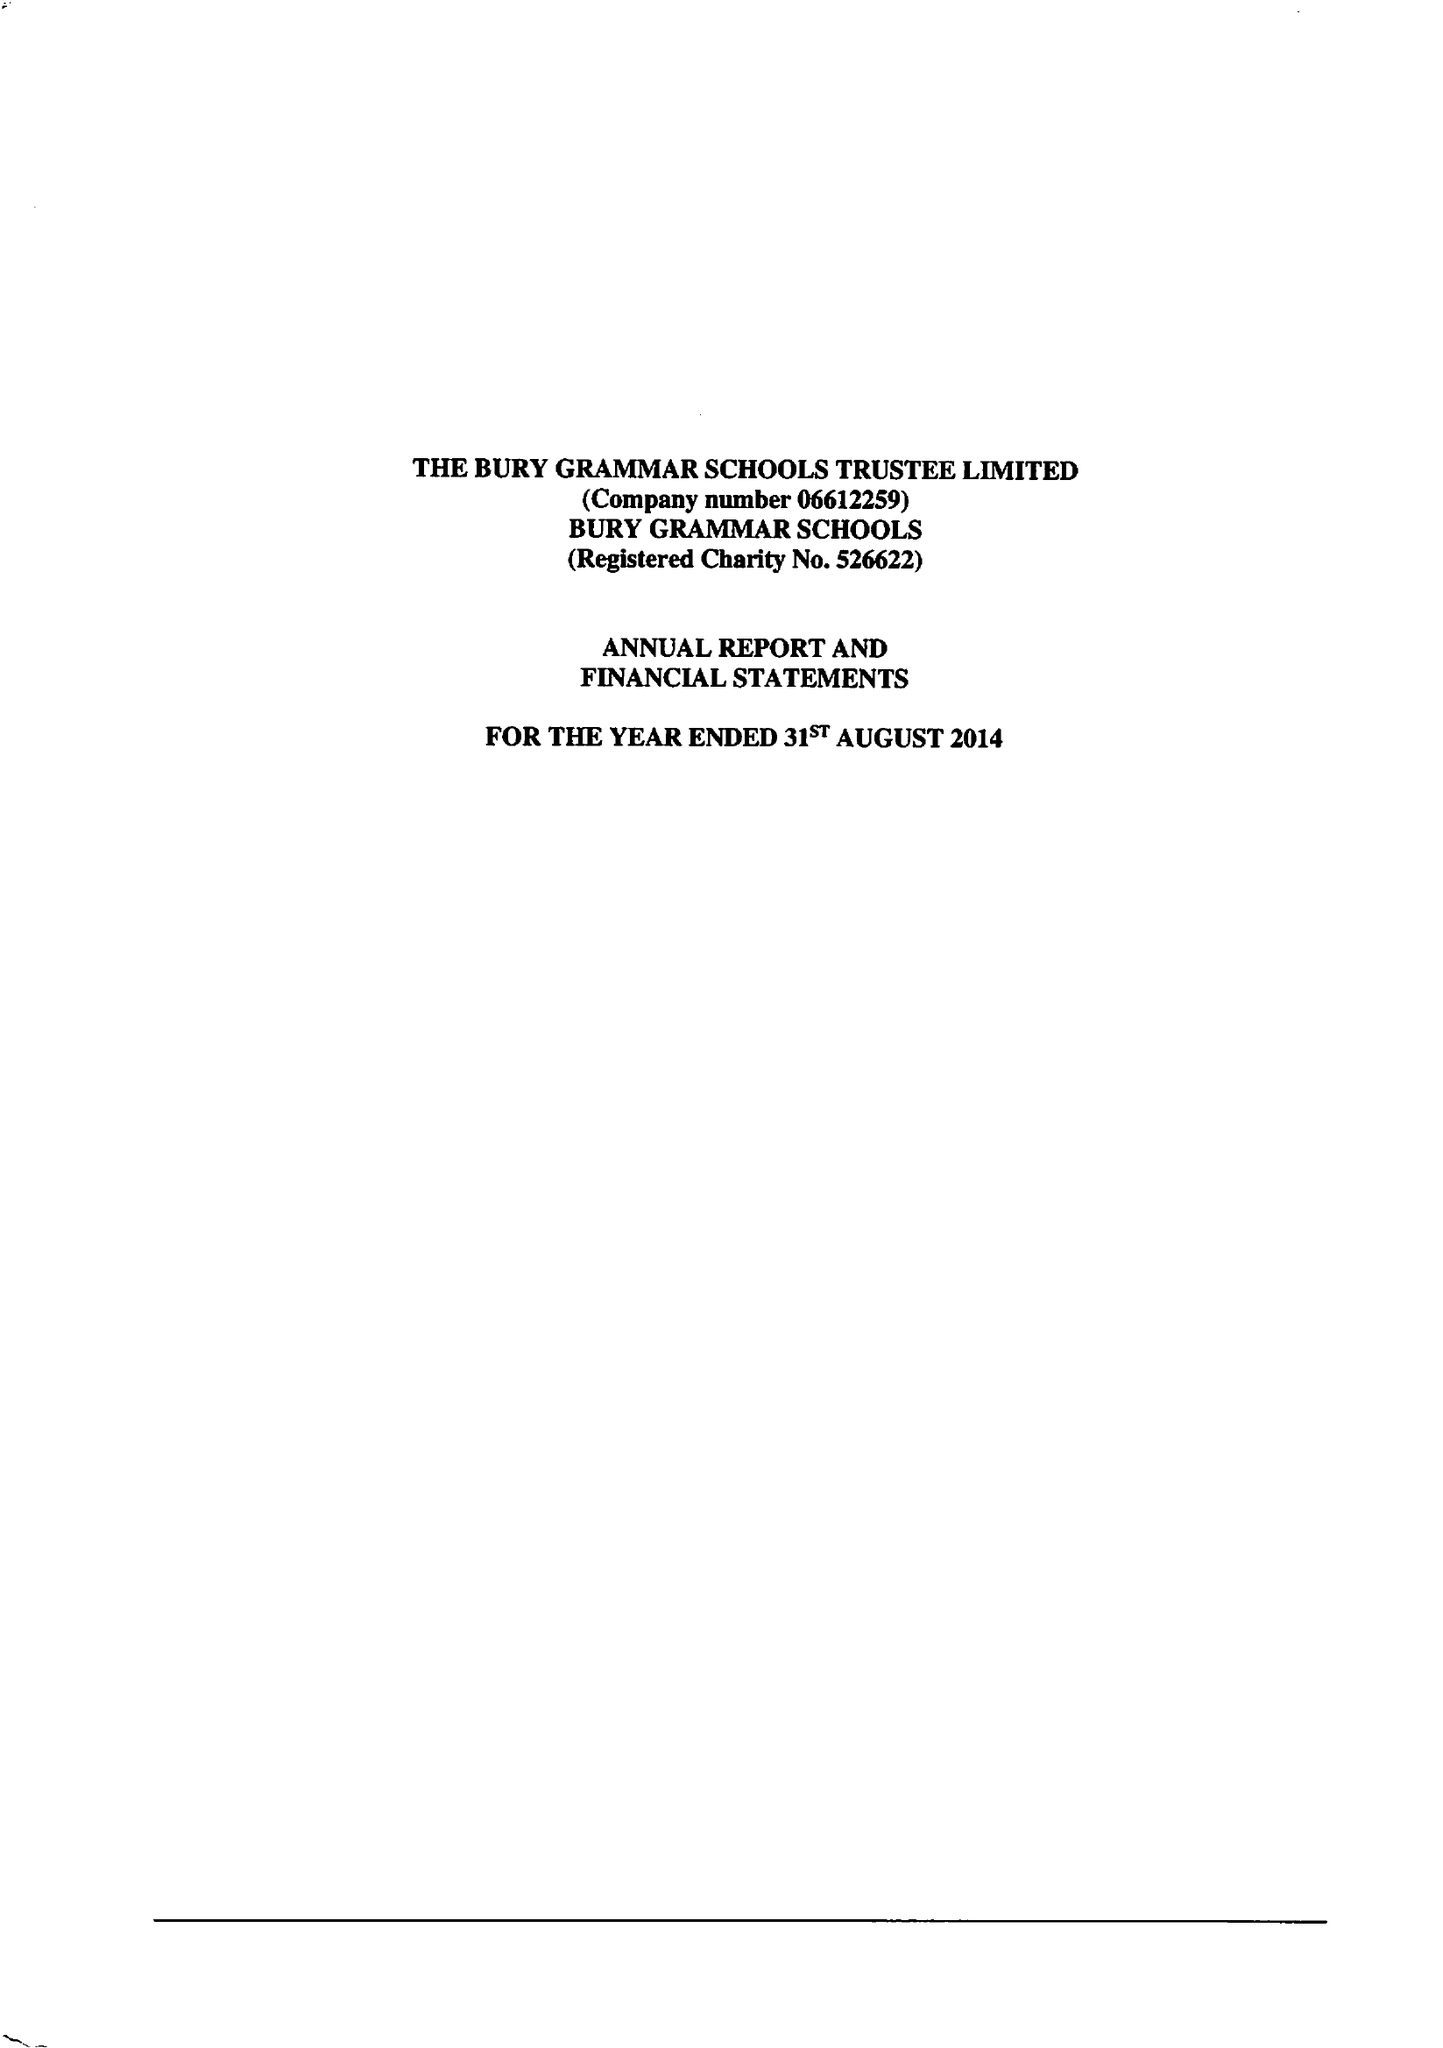What is the value for the charity_name?
Answer the question using a single word or phrase. Bury Grammar Schools Trustee Ltd. 